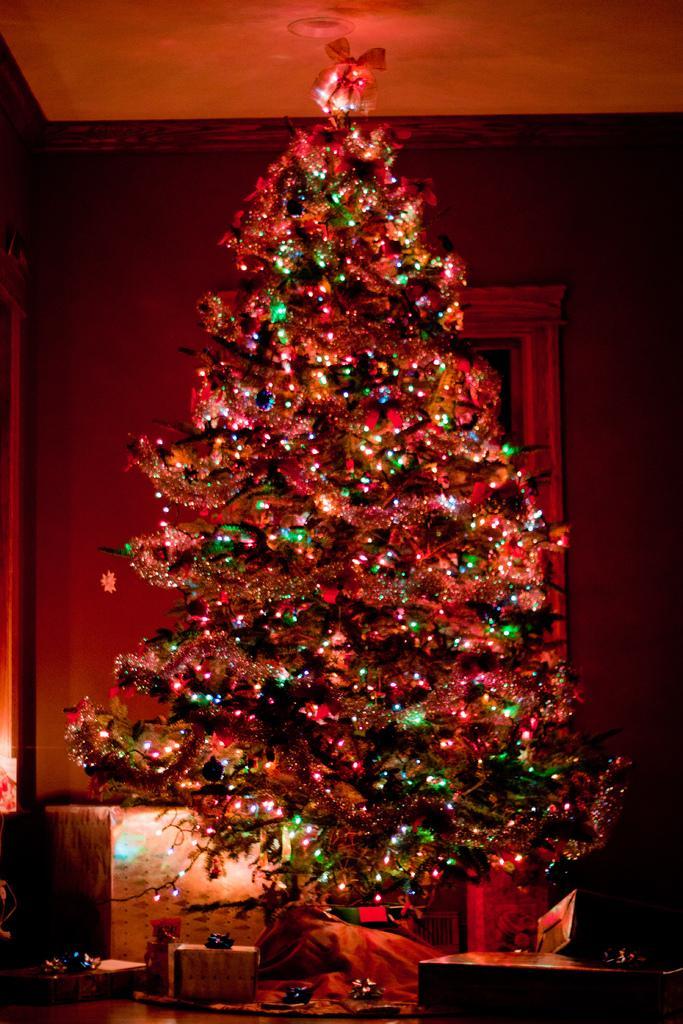Describe this image in one or two sentences. In this image there is a Christmas tree, there are few gift boxes on the table and another box behind the tree. 